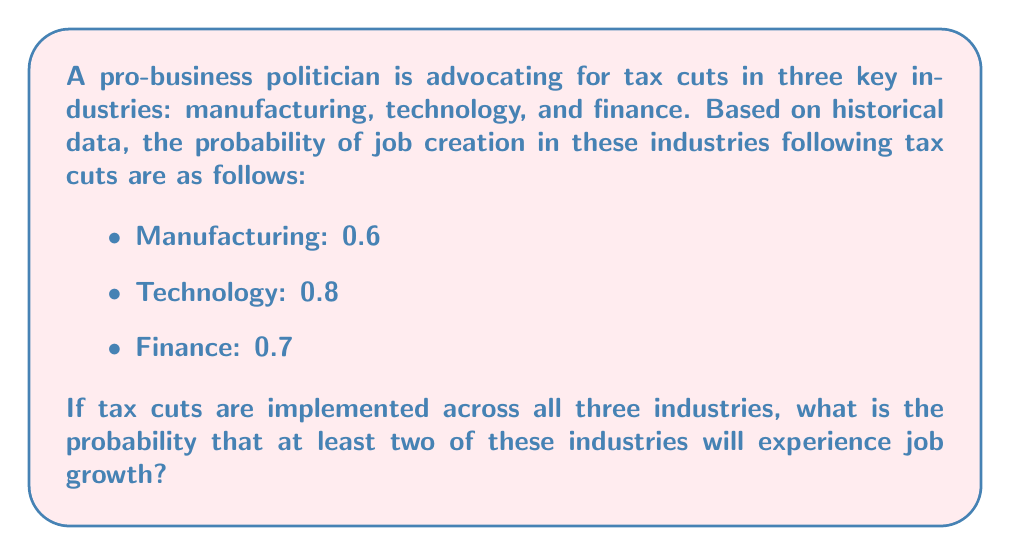Show me your answer to this math problem. To solve this problem, we'll use Bayesian probability and the concept of complementary events.

Let's define the events:
M: Job growth in Manufacturing
T: Job growth in Technology
F: Job growth in Finance

We want to find P(at least two industries experience job growth).

Step 1: It's easier to calculate the complement of this event, which is the probability that 0 or 1 industry experiences job growth.

Step 2: Calculate the probability of no job growth in any industry:
$$P(\text{no growth}) = (1-0.6) \times (1-0.8) \times (1-0.7) = 0.4 \times 0.2 \times 0.3 = 0.024$$

Step 3: Calculate the probability of job growth in exactly one industry:

For Manufacturing only: $$0.6 \times 0.2 \times 0.3 = 0.036$$
For Technology only: $$0.4 \times 0.8 \times 0.3 = 0.096$$
For Finance only: $$0.4 \times 0.2 \times 0.7 = 0.056$$

Sum these probabilities: $$0.036 + 0.096 + 0.056 = 0.188$$

Step 4: Sum the probabilities of 0 and 1 industry experiencing growth:
$$P(0 \text{ or } 1) = 0.024 + 0.188 = 0.212$$

Step 5: The probability of at least two industries experiencing job growth is the complement of this probability:
$$P(\text{at least two}) = 1 - P(0 \text{ or } 1) = 1 - 0.212 = 0.788$$
Answer: The probability that at least two of these industries will experience job growth following tax cuts is 0.788 or 78.8%. 